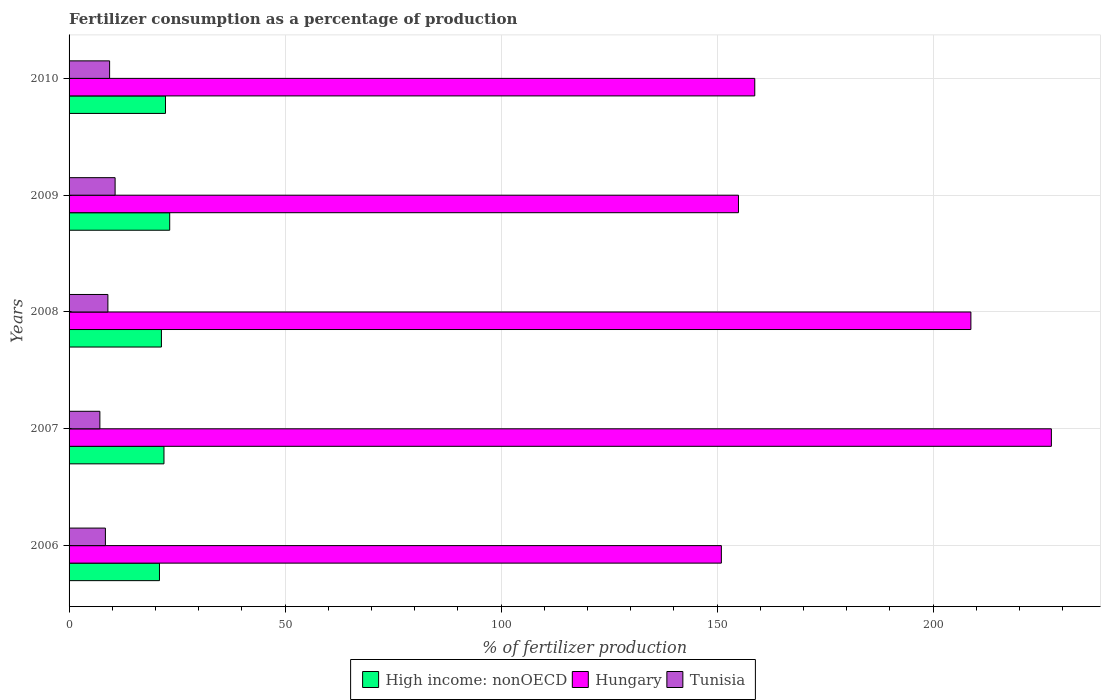How many different coloured bars are there?
Your answer should be very brief. 3. How many groups of bars are there?
Keep it short and to the point. 5. Are the number of bars on each tick of the Y-axis equal?
Offer a very short reply. Yes. How many bars are there on the 4th tick from the bottom?
Keep it short and to the point. 3. What is the percentage of fertilizers consumed in High income: nonOECD in 2010?
Ensure brevity in your answer.  22.32. Across all years, what is the maximum percentage of fertilizers consumed in Hungary?
Your response must be concise. 227.39. Across all years, what is the minimum percentage of fertilizers consumed in Hungary?
Offer a terse response. 150.99. In which year was the percentage of fertilizers consumed in High income: nonOECD maximum?
Give a very brief answer. 2009. In which year was the percentage of fertilizers consumed in Hungary minimum?
Make the answer very short. 2006. What is the total percentage of fertilizers consumed in Tunisia in the graph?
Give a very brief answer. 44.57. What is the difference between the percentage of fertilizers consumed in Tunisia in 2009 and that in 2010?
Provide a succinct answer. 1.27. What is the difference between the percentage of fertilizers consumed in Tunisia in 2010 and the percentage of fertilizers consumed in High income: nonOECD in 2009?
Keep it short and to the point. -13.91. What is the average percentage of fertilizers consumed in Tunisia per year?
Provide a short and direct response. 8.91. In the year 2006, what is the difference between the percentage of fertilizers consumed in Tunisia and percentage of fertilizers consumed in Hungary?
Your answer should be very brief. -142.58. In how many years, is the percentage of fertilizers consumed in Hungary greater than 70 %?
Offer a terse response. 5. What is the ratio of the percentage of fertilizers consumed in Tunisia in 2006 to that in 2007?
Keep it short and to the point. 1.18. Is the percentage of fertilizers consumed in Hungary in 2008 less than that in 2009?
Provide a short and direct response. No. What is the difference between the highest and the second highest percentage of fertilizers consumed in High income: nonOECD?
Provide a short and direct response. 0.97. What is the difference between the highest and the lowest percentage of fertilizers consumed in Hungary?
Provide a succinct answer. 76.39. In how many years, is the percentage of fertilizers consumed in High income: nonOECD greater than the average percentage of fertilizers consumed in High income: nonOECD taken over all years?
Provide a short and direct response. 2. Is the sum of the percentage of fertilizers consumed in High income: nonOECD in 2008 and 2009 greater than the maximum percentage of fertilizers consumed in Hungary across all years?
Ensure brevity in your answer.  No. What does the 3rd bar from the top in 2008 represents?
Offer a very short reply. High income: nonOECD. What does the 1st bar from the bottom in 2010 represents?
Your answer should be compact. High income: nonOECD. Is it the case that in every year, the sum of the percentage of fertilizers consumed in Hungary and percentage of fertilizers consumed in Tunisia is greater than the percentage of fertilizers consumed in High income: nonOECD?
Give a very brief answer. Yes. Are all the bars in the graph horizontal?
Provide a short and direct response. Yes. Are the values on the major ticks of X-axis written in scientific E-notation?
Keep it short and to the point. No. Does the graph contain grids?
Your answer should be compact. Yes. How many legend labels are there?
Keep it short and to the point. 3. What is the title of the graph?
Ensure brevity in your answer.  Fertilizer consumption as a percentage of production. Does "Northern Mariana Islands" appear as one of the legend labels in the graph?
Provide a succinct answer. No. What is the label or title of the X-axis?
Provide a short and direct response. % of fertilizer production. What is the label or title of the Y-axis?
Offer a terse response. Years. What is the % of fertilizer production in High income: nonOECD in 2006?
Ensure brevity in your answer.  20.93. What is the % of fertilizer production of Hungary in 2006?
Keep it short and to the point. 150.99. What is the % of fertilizer production in Tunisia in 2006?
Provide a succinct answer. 8.41. What is the % of fertilizer production of High income: nonOECD in 2007?
Your answer should be compact. 21.97. What is the % of fertilizer production in Hungary in 2007?
Your response must be concise. 227.39. What is the % of fertilizer production of Tunisia in 2007?
Offer a terse response. 7.13. What is the % of fertilizer production of High income: nonOECD in 2008?
Give a very brief answer. 21.38. What is the % of fertilizer production in Hungary in 2008?
Offer a terse response. 208.76. What is the % of fertilizer production of Tunisia in 2008?
Provide a short and direct response. 8.99. What is the % of fertilizer production in High income: nonOECD in 2009?
Offer a terse response. 23.29. What is the % of fertilizer production of Hungary in 2009?
Your answer should be very brief. 154.95. What is the % of fertilizer production of Tunisia in 2009?
Your answer should be compact. 10.66. What is the % of fertilizer production in High income: nonOECD in 2010?
Make the answer very short. 22.32. What is the % of fertilizer production in Hungary in 2010?
Offer a very short reply. 158.73. What is the % of fertilizer production of Tunisia in 2010?
Provide a succinct answer. 9.38. Across all years, what is the maximum % of fertilizer production of High income: nonOECD?
Make the answer very short. 23.29. Across all years, what is the maximum % of fertilizer production of Hungary?
Keep it short and to the point. 227.39. Across all years, what is the maximum % of fertilizer production in Tunisia?
Your answer should be very brief. 10.66. Across all years, what is the minimum % of fertilizer production of High income: nonOECD?
Offer a very short reply. 20.93. Across all years, what is the minimum % of fertilizer production in Hungary?
Offer a terse response. 150.99. Across all years, what is the minimum % of fertilizer production of Tunisia?
Provide a succinct answer. 7.13. What is the total % of fertilizer production in High income: nonOECD in the graph?
Ensure brevity in your answer.  109.88. What is the total % of fertilizer production of Hungary in the graph?
Ensure brevity in your answer.  900.82. What is the total % of fertilizer production in Tunisia in the graph?
Ensure brevity in your answer.  44.57. What is the difference between the % of fertilizer production in High income: nonOECD in 2006 and that in 2007?
Give a very brief answer. -1.04. What is the difference between the % of fertilizer production of Hungary in 2006 and that in 2007?
Give a very brief answer. -76.39. What is the difference between the % of fertilizer production of Tunisia in 2006 and that in 2007?
Provide a succinct answer. 1.28. What is the difference between the % of fertilizer production of High income: nonOECD in 2006 and that in 2008?
Offer a terse response. -0.45. What is the difference between the % of fertilizer production in Hungary in 2006 and that in 2008?
Offer a very short reply. -57.76. What is the difference between the % of fertilizer production of Tunisia in 2006 and that in 2008?
Your answer should be very brief. -0.57. What is the difference between the % of fertilizer production of High income: nonOECD in 2006 and that in 2009?
Keep it short and to the point. -2.37. What is the difference between the % of fertilizer production in Hungary in 2006 and that in 2009?
Offer a terse response. -3.96. What is the difference between the % of fertilizer production of Tunisia in 2006 and that in 2009?
Offer a very short reply. -2.24. What is the difference between the % of fertilizer production in High income: nonOECD in 2006 and that in 2010?
Offer a very short reply. -1.39. What is the difference between the % of fertilizer production in Hungary in 2006 and that in 2010?
Ensure brevity in your answer.  -7.73. What is the difference between the % of fertilizer production of Tunisia in 2006 and that in 2010?
Offer a terse response. -0.97. What is the difference between the % of fertilizer production of High income: nonOECD in 2007 and that in 2008?
Offer a terse response. 0.59. What is the difference between the % of fertilizer production of Hungary in 2007 and that in 2008?
Make the answer very short. 18.63. What is the difference between the % of fertilizer production in Tunisia in 2007 and that in 2008?
Offer a terse response. -1.86. What is the difference between the % of fertilizer production in High income: nonOECD in 2007 and that in 2009?
Keep it short and to the point. -1.33. What is the difference between the % of fertilizer production of Hungary in 2007 and that in 2009?
Provide a short and direct response. 72.43. What is the difference between the % of fertilizer production in Tunisia in 2007 and that in 2009?
Your response must be concise. -3.53. What is the difference between the % of fertilizer production of High income: nonOECD in 2007 and that in 2010?
Make the answer very short. -0.35. What is the difference between the % of fertilizer production in Hungary in 2007 and that in 2010?
Give a very brief answer. 68.66. What is the difference between the % of fertilizer production of Tunisia in 2007 and that in 2010?
Your answer should be compact. -2.25. What is the difference between the % of fertilizer production of High income: nonOECD in 2008 and that in 2009?
Ensure brevity in your answer.  -1.91. What is the difference between the % of fertilizer production of Hungary in 2008 and that in 2009?
Give a very brief answer. 53.8. What is the difference between the % of fertilizer production of Tunisia in 2008 and that in 2009?
Your answer should be compact. -1.67. What is the difference between the % of fertilizer production in High income: nonOECD in 2008 and that in 2010?
Offer a very short reply. -0.94. What is the difference between the % of fertilizer production of Hungary in 2008 and that in 2010?
Make the answer very short. 50.03. What is the difference between the % of fertilizer production of Tunisia in 2008 and that in 2010?
Keep it short and to the point. -0.4. What is the difference between the % of fertilizer production in Hungary in 2009 and that in 2010?
Provide a succinct answer. -3.77. What is the difference between the % of fertilizer production of Tunisia in 2009 and that in 2010?
Your answer should be compact. 1.27. What is the difference between the % of fertilizer production in High income: nonOECD in 2006 and the % of fertilizer production in Hungary in 2007?
Keep it short and to the point. -206.46. What is the difference between the % of fertilizer production of High income: nonOECD in 2006 and the % of fertilizer production of Tunisia in 2007?
Your answer should be compact. 13.8. What is the difference between the % of fertilizer production in Hungary in 2006 and the % of fertilizer production in Tunisia in 2007?
Keep it short and to the point. 143.86. What is the difference between the % of fertilizer production in High income: nonOECD in 2006 and the % of fertilizer production in Hungary in 2008?
Give a very brief answer. -187.83. What is the difference between the % of fertilizer production in High income: nonOECD in 2006 and the % of fertilizer production in Tunisia in 2008?
Your answer should be very brief. 11.94. What is the difference between the % of fertilizer production of Hungary in 2006 and the % of fertilizer production of Tunisia in 2008?
Provide a succinct answer. 142.01. What is the difference between the % of fertilizer production in High income: nonOECD in 2006 and the % of fertilizer production in Hungary in 2009?
Provide a succinct answer. -134.03. What is the difference between the % of fertilizer production in High income: nonOECD in 2006 and the % of fertilizer production in Tunisia in 2009?
Provide a succinct answer. 10.27. What is the difference between the % of fertilizer production of Hungary in 2006 and the % of fertilizer production of Tunisia in 2009?
Provide a short and direct response. 140.34. What is the difference between the % of fertilizer production in High income: nonOECD in 2006 and the % of fertilizer production in Hungary in 2010?
Your answer should be compact. -137.8. What is the difference between the % of fertilizer production in High income: nonOECD in 2006 and the % of fertilizer production in Tunisia in 2010?
Give a very brief answer. 11.54. What is the difference between the % of fertilizer production in Hungary in 2006 and the % of fertilizer production in Tunisia in 2010?
Keep it short and to the point. 141.61. What is the difference between the % of fertilizer production of High income: nonOECD in 2007 and the % of fertilizer production of Hungary in 2008?
Your answer should be compact. -186.79. What is the difference between the % of fertilizer production of High income: nonOECD in 2007 and the % of fertilizer production of Tunisia in 2008?
Provide a short and direct response. 12.98. What is the difference between the % of fertilizer production of Hungary in 2007 and the % of fertilizer production of Tunisia in 2008?
Provide a short and direct response. 218.4. What is the difference between the % of fertilizer production of High income: nonOECD in 2007 and the % of fertilizer production of Hungary in 2009?
Offer a very short reply. -132.99. What is the difference between the % of fertilizer production of High income: nonOECD in 2007 and the % of fertilizer production of Tunisia in 2009?
Keep it short and to the point. 11.31. What is the difference between the % of fertilizer production in Hungary in 2007 and the % of fertilizer production in Tunisia in 2009?
Offer a very short reply. 216.73. What is the difference between the % of fertilizer production in High income: nonOECD in 2007 and the % of fertilizer production in Hungary in 2010?
Your response must be concise. -136.76. What is the difference between the % of fertilizer production in High income: nonOECD in 2007 and the % of fertilizer production in Tunisia in 2010?
Offer a very short reply. 12.58. What is the difference between the % of fertilizer production of Hungary in 2007 and the % of fertilizer production of Tunisia in 2010?
Provide a succinct answer. 218. What is the difference between the % of fertilizer production in High income: nonOECD in 2008 and the % of fertilizer production in Hungary in 2009?
Offer a terse response. -133.57. What is the difference between the % of fertilizer production in High income: nonOECD in 2008 and the % of fertilizer production in Tunisia in 2009?
Give a very brief answer. 10.72. What is the difference between the % of fertilizer production in Hungary in 2008 and the % of fertilizer production in Tunisia in 2009?
Keep it short and to the point. 198.1. What is the difference between the % of fertilizer production in High income: nonOECD in 2008 and the % of fertilizer production in Hungary in 2010?
Keep it short and to the point. -137.35. What is the difference between the % of fertilizer production in High income: nonOECD in 2008 and the % of fertilizer production in Tunisia in 2010?
Your response must be concise. 12. What is the difference between the % of fertilizer production of Hungary in 2008 and the % of fertilizer production of Tunisia in 2010?
Offer a very short reply. 199.37. What is the difference between the % of fertilizer production of High income: nonOECD in 2009 and the % of fertilizer production of Hungary in 2010?
Provide a short and direct response. -135.43. What is the difference between the % of fertilizer production in High income: nonOECD in 2009 and the % of fertilizer production in Tunisia in 2010?
Make the answer very short. 13.91. What is the difference between the % of fertilizer production in Hungary in 2009 and the % of fertilizer production in Tunisia in 2010?
Offer a terse response. 145.57. What is the average % of fertilizer production in High income: nonOECD per year?
Keep it short and to the point. 21.98. What is the average % of fertilizer production in Hungary per year?
Offer a terse response. 180.16. What is the average % of fertilizer production in Tunisia per year?
Your answer should be very brief. 8.91. In the year 2006, what is the difference between the % of fertilizer production of High income: nonOECD and % of fertilizer production of Hungary?
Offer a very short reply. -130.07. In the year 2006, what is the difference between the % of fertilizer production of High income: nonOECD and % of fertilizer production of Tunisia?
Provide a succinct answer. 12.51. In the year 2006, what is the difference between the % of fertilizer production of Hungary and % of fertilizer production of Tunisia?
Provide a short and direct response. 142.58. In the year 2007, what is the difference between the % of fertilizer production in High income: nonOECD and % of fertilizer production in Hungary?
Offer a very short reply. -205.42. In the year 2007, what is the difference between the % of fertilizer production in High income: nonOECD and % of fertilizer production in Tunisia?
Provide a short and direct response. 14.84. In the year 2007, what is the difference between the % of fertilizer production of Hungary and % of fertilizer production of Tunisia?
Ensure brevity in your answer.  220.26. In the year 2008, what is the difference between the % of fertilizer production in High income: nonOECD and % of fertilizer production in Hungary?
Your response must be concise. -187.38. In the year 2008, what is the difference between the % of fertilizer production of High income: nonOECD and % of fertilizer production of Tunisia?
Offer a very short reply. 12.39. In the year 2008, what is the difference between the % of fertilizer production of Hungary and % of fertilizer production of Tunisia?
Provide a succinct answer. 199.77. In the year 2009, what is the difference between the % of fertilizer production in High income: nonOECD and % of fertilizer production in Hungary?
Offer a very short reply. -131.66. In the year 2009, what is the difference between the % of fertilizer production of High income: nonOECD and % of fertilizer production of Tunisia?
Ensure brevity in your answer.  12.64. In the year 2009, what is the difference between the % of fertilizer production of Hungary and % of fertilizer production of Tunisia?
Offer a very short reply. 144.3. In the year 2010, what is the difference between the % of fertilizer production in High income: nonOECD and % of fertilizer production in Hungary?
Your answer should be very brief. -136.41. In the year 2010, what is the difference between the % of fertilizer production in High income: nonOECD and % of fertilizer production in Tunisia?
Your response must be concise. 12.93. In the year 2010, what is the difference between the % of fertilizer production of Hungary and % of fertilizer production of Tunisia?
Offer a very short reply. 149.34. What is the ratio of the % of fertilizer production of High income: nonOECD in 2006 to that in 2007?
Provide a succinct answer. 0.95. What is the ratio of the % of fertilizer production in Hungary in 2006 to that in 2007?
Provide a short and direct response. 0.66. What is the ratio of the % of fertilizer production in Tunisia in 2006 to that in 2007?
Provide a short and direct response. 1.18. What is the ratio of the % of fertilizer production in High income: nonOECD in 2006 to that in 2008?
Your answer should be compact. 0.98. What is the ratio of the % of fertilizer production in Hungary in 2006 to that in 2008?
Your response must be concise. 0.72. What is the ratio of the % of fertilizer production in Tunisia in 2006 to that in 2008?
Make the answer very short. 0.94. What is the ratio of the % of fertilizer production of High income: nonOECD in 2006 to that in 2009?
Provide a succinct answer. 0.9. What is the ratio of the % of fertilizer production of Hungary in 2006 to that in 2009?
Give a very brief answer. 0.97. What is the ratio of the % of fertilizer production of Tunisia in 2006 to that in 2009?
Provide a short and direct response. 0.79. What is the ratio of the % of fertilizer production of High income: nonOECD in 2006 to that in 2010?
Your answer should be compact. 0.94. What is the ratio of the % of fertilizer production of Hungary in 2006 to that in 2010?
Make the answer very short. 0.95. What is the ratio of the % of fertilizer production in Tunisia in 2006 to that in 2010?
Keep it short and to the point. 0.9. What is the ratio of the % of fertilizer production in High income: nonOECD in 2007 to that in 2008?
Keep it short and to the point. 1.03. What is the ratio of the % of fertilizer production in Hungary in 2007 to that in 2008?
Offer a terse response. 1.09. What is the ratio of the % of fertilizer production in Tunisia in 2007 to that in 2008?
Give a very brief answer. 0.79. What is the ratio of the % of fertilizer production in High income: nonOECD in 2007 to that in 2009?
Your response must be concise. 0.94. What is the ratio of the % of fertilizer production of Hungary in 2007 to that in 2009?
Provide a short and direct response. 1.47. What is the ratio of the % of fertilizer production in Tunisia in 2007 to that in 2009?
Make the answer very short. 0.67. What is the ratio of the % of fertilizer production of High income: nonOECD in 2007 to that in 2010?
Provide a short and direct response. 0.98. What is the ratio of the % of fertilizer production in Hungary in 2007 to that in 2010?
Your answer should be compact. 1.43. What is the ratio of the % of fertilizer production of Tunisia in 2007 to that in 2010?
Your answer should be compact. 0.76. What is the ratio of the % of fertilizer production of High income: nonOECD in 2008 to that in 2009?
Give a very brief answer. 0.92. What is the ratio of the % of fertilizer production in Hungary in 2008 to that in 2009?
Provide a succinct answer. 1.35. What is the ratio of the % of fertilizer production in Tunisia in 2008 to that in 2009?
Ensure brevity in your answer.  0.84. What is the ratio of the % of fertilizer production of High income: nonOECD in 2008 to that in 2010?
Ensure brevity in your answer.  0.96. What is the ratio of the % of fertilizer production of Hungary in 2008 to that in 2010?
Provide a succinct answer. 1.32. What is the ratio of the % of fertilizer production of Tunisia in 2008 to that in 2010?
Your answer should be compact. 0.96. What is the ratio of the % of fertilizer production of High income: nonOECD in 2009 to that in 2010?
Your response must be concise. 1.04. What is the ratio of the % of fertilizer production in Hungary in 2009 to that in 2010?
Your answer should be compact. 0.98. What is the ratio of the % of fertilizer production in Tunisia in 2009 to that in 2010?
Keep it short and to the point. 1.14. What is the difference between the highest and the second highest % of fertilizer production in High income: nonOECD?
Provide a succinct answer. 0.97. What is the difference between the highest and the second highest % of fertilizer production of Hungary?
Your response must be concise. 18.63. What is the difference between the highest and the second highest % of fertilizer production of Tunisia?
Offer a very short reply. 1.27. What is the difference between the highest and the lowest % of fertilizer production of High income: nonOECD?
Offer a terse response. 2.37. What is the difference between the highest and the lowest % of fertilizer production in Hungary?
Offer a terse response. 76.39. What is the difference between the highest and the lowest % of fertilizer production in Tunisia?
Provide a succinct answer. 3.53. 